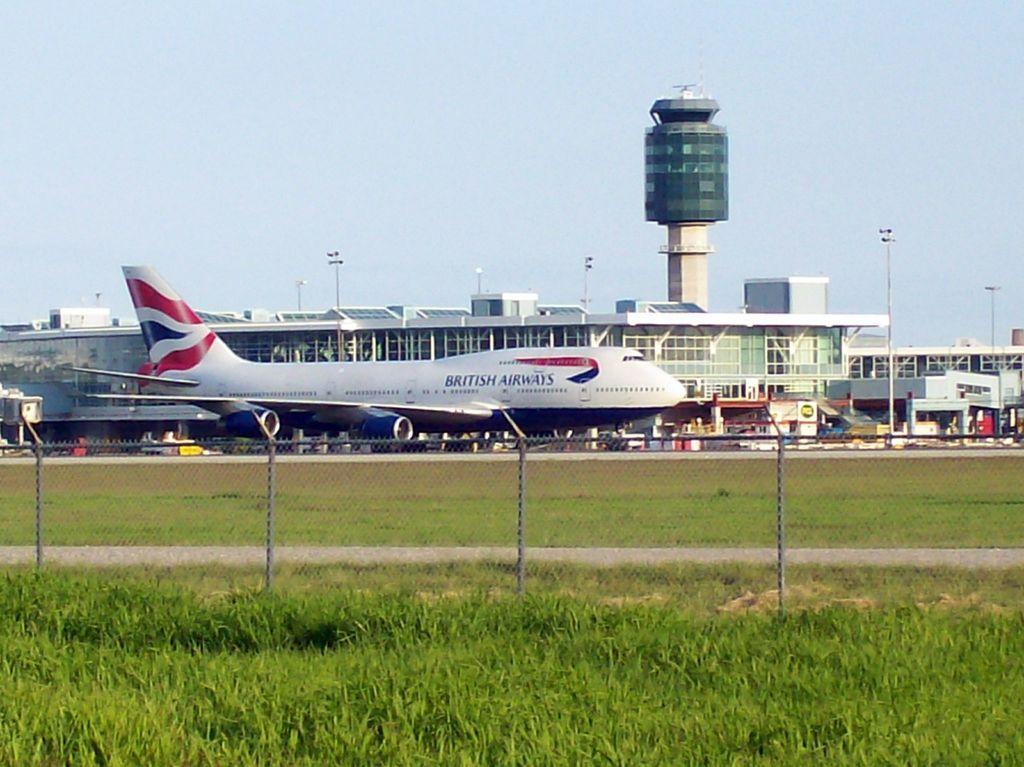Please provide a concise description of this image. In this image at the bottom there is grass and fence, and in the background there are some buildings, airplane, poles, lights, tower and some other objects. At the top there is sky. 